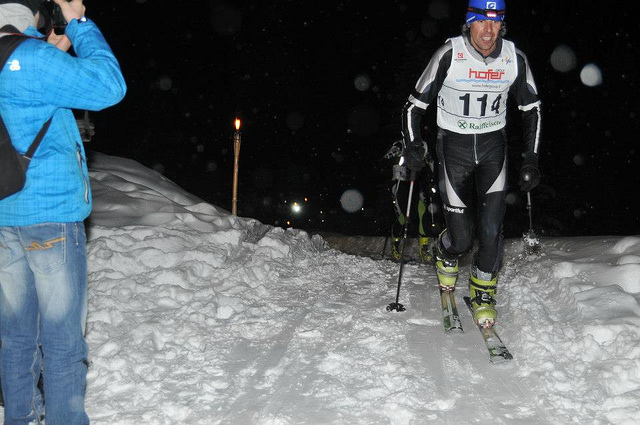Please identify all text content in this image. hofer 114 